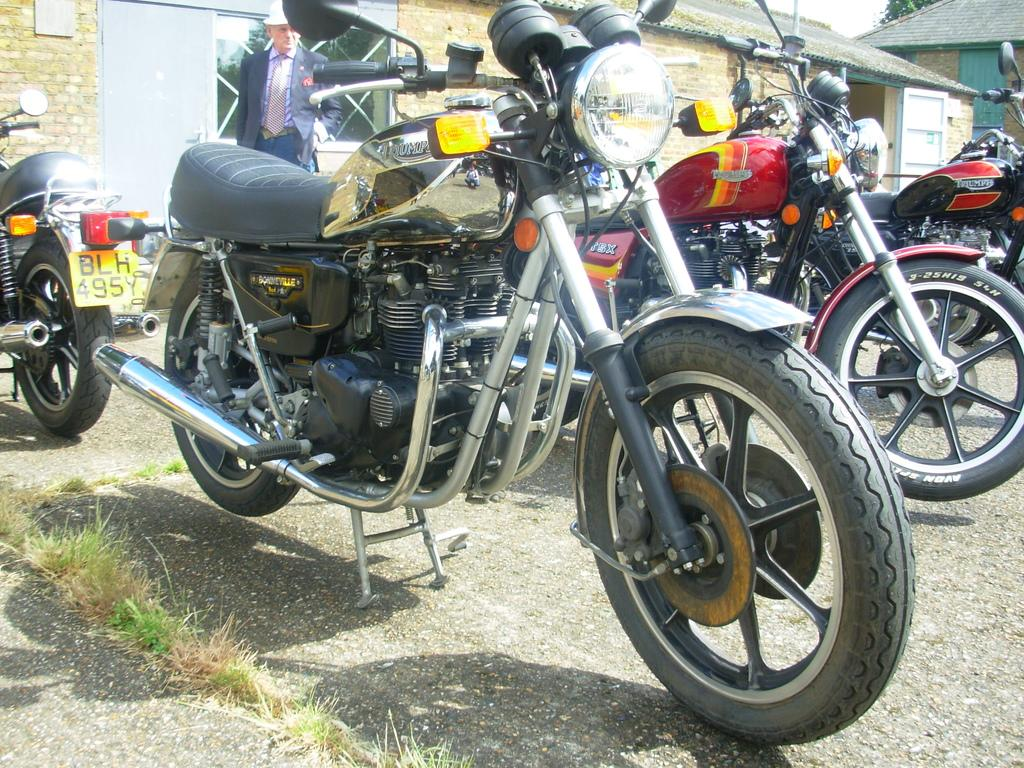What type of vehicles are in the image? There are motorcycles in the image. Can you describe the person in the image? There is a person in the image. What is the ground surface like in the image? There is grass on the ground in the image. What can be seen in the background of the image? There are houses in the background of the image. What features do the houses have? The houses have doors and windows. What else is visible in the background of the image? There is an object in the background of the image. Where is the tree located in the image? The tree is visible in the top right of the image. What is visible in the sky in the image? The sky is visible in the image. What type of advertisement can be seen on the motorcycles in the image? There is no advertisement visible on the motorcycles in the image. What type of bean is growing in the plantation visible in the image? There is no plantation visible in the image, so it is not possible to determine what type of bean might be growing there. 